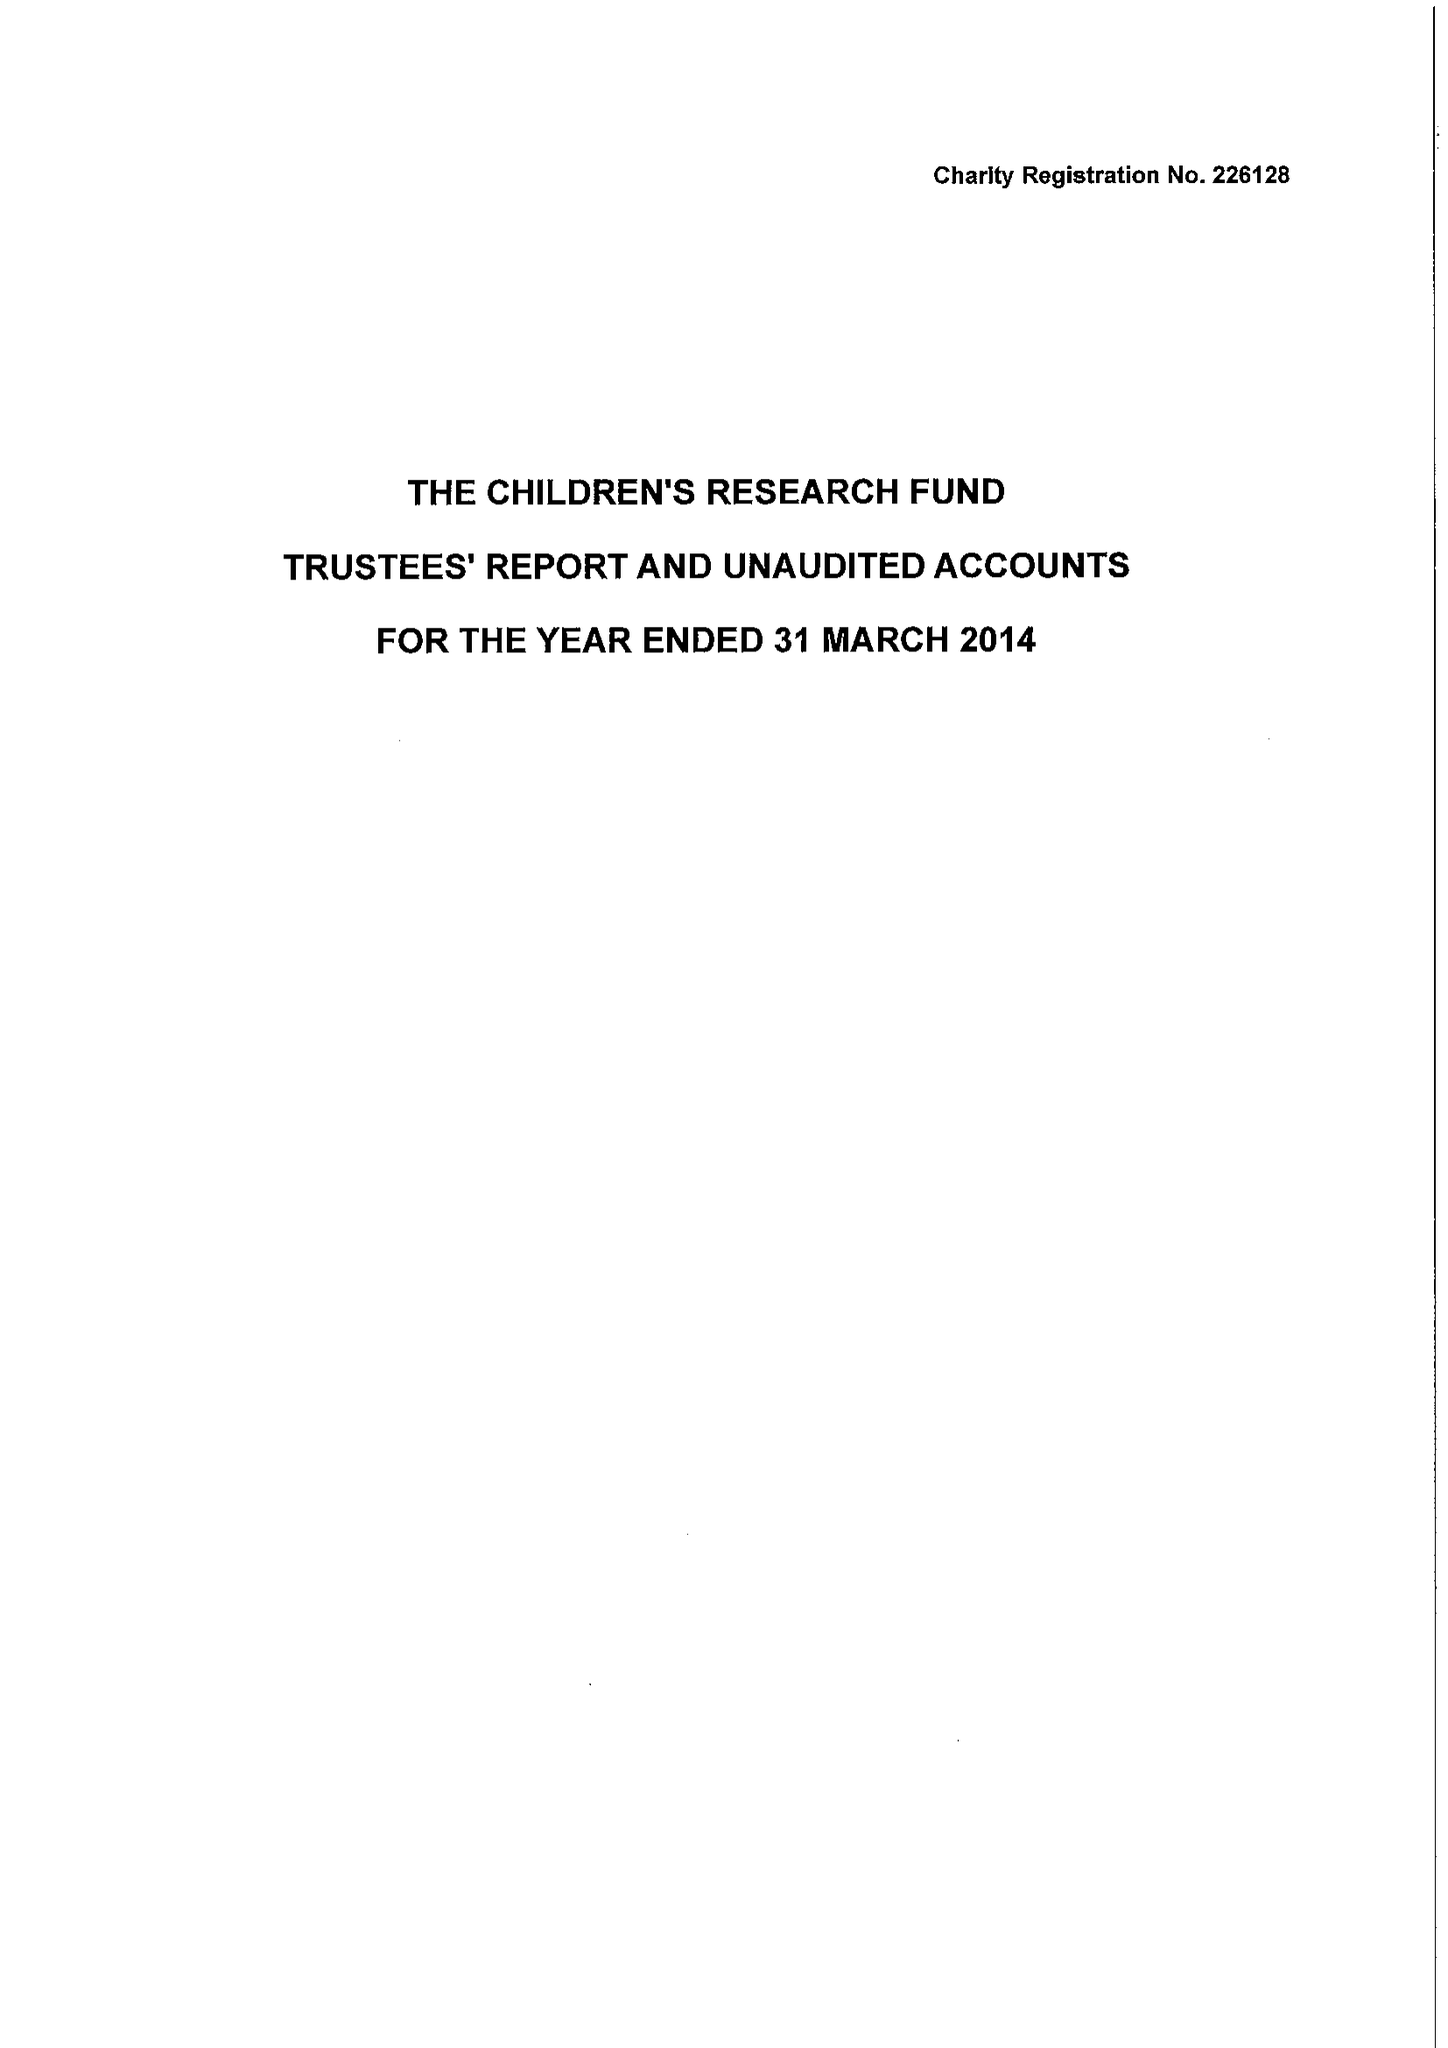What is the value for the address__postcode?
Answer the question using a single word or phrase. LL15 1AQ 